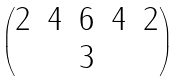Convert formula to latex. <formula><loc_0><loc_0><loc_500><loc_500>\begin{pmatrix} 2 & 4 & 6 & 4 & 2 \\ & & 3 & & \end{pmatrix}</formula> 